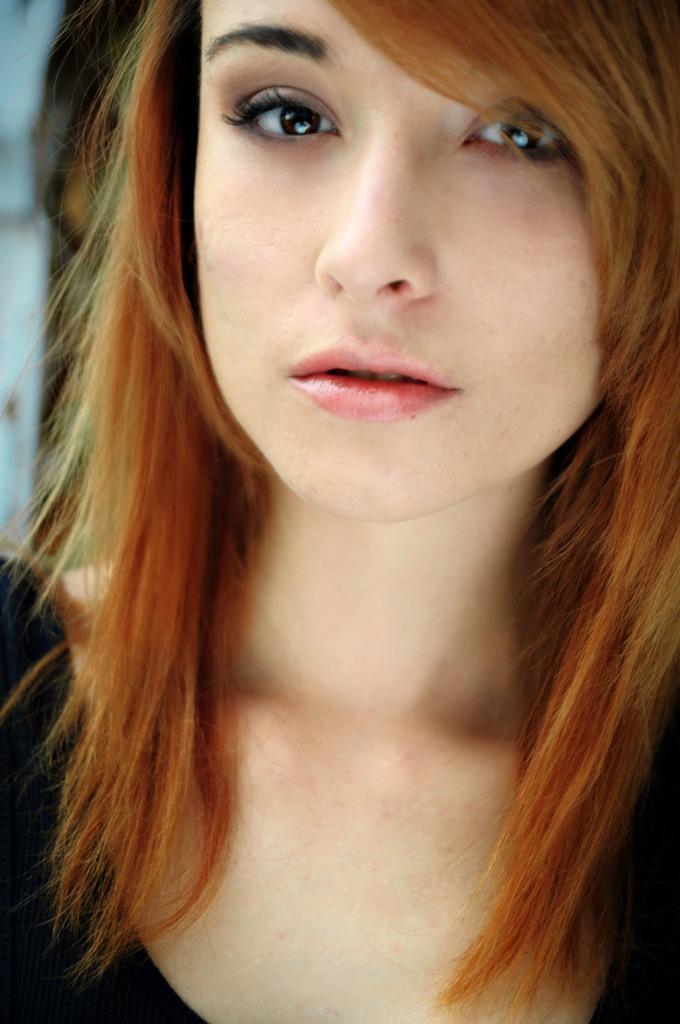Could you give a brief overview of what you see in this image? In this image I can see a woman. I can see she is wearing black colour dress. 